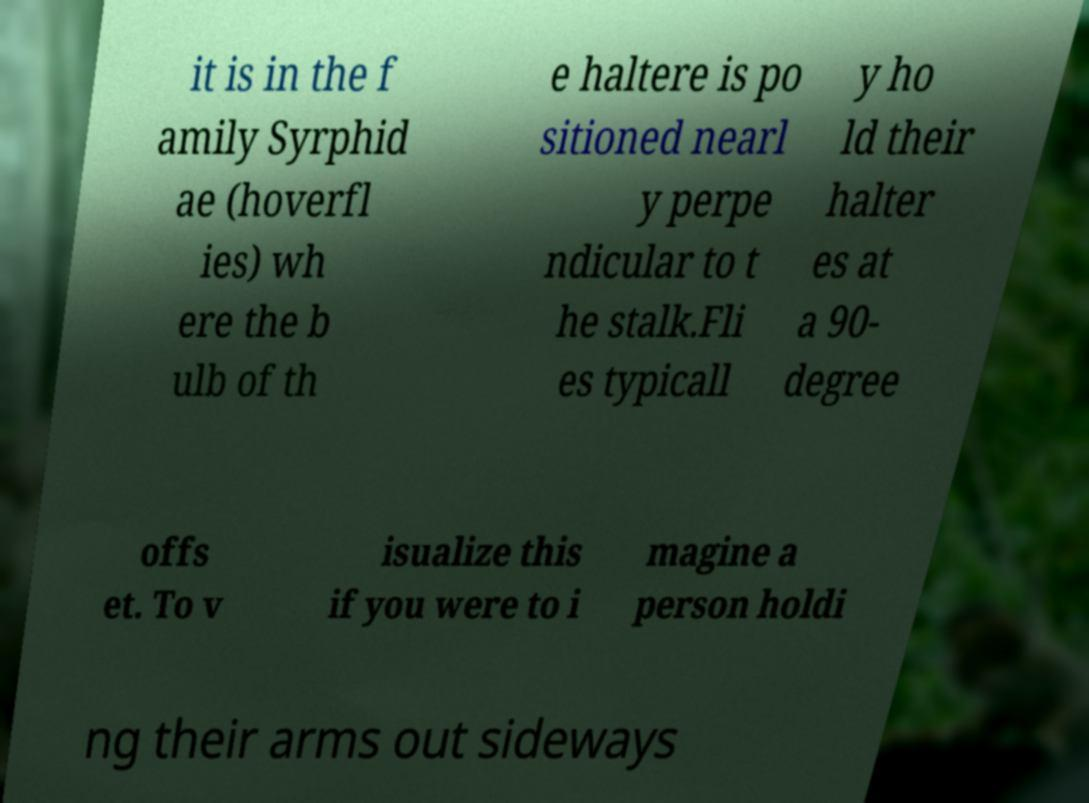Can you read and provide the text displayed in the image?This photo seems to have some interesting text. Can you extract and type it out for me? it is in the f amily Syrphid ae (hoverfl ies) wh ere the b ulb of th e haltere is po sitioned nearl y perpe ndicular to t he stalk.Fli es typicall y ho ld their halter es at a 90- degree offs et. To v isualize this if you were to i magine a person holdi ng their arms out sideways 